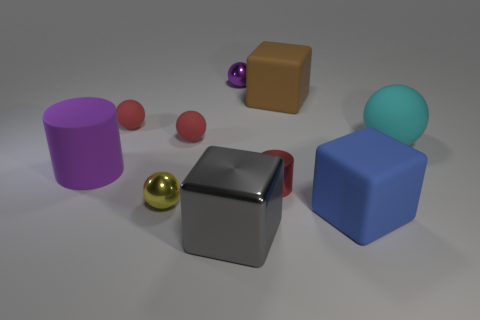Subtract all yellow shiny balls. How many balls are left? 4 Subtract all blue cubes. How many cubes are left? 2 Subtract all blocks. How many objects are left? 7 Subtract 0 blue cylinders. How many objects are left? 10 Subtract 1 cubes. How many cubes are left? 2 Subtract all purple cylinders. Subtract all red balls. How many cylinders are left? 1 Subtract all cyan spheres. How many blue cylinders are left? 0 Subtract all small yellow metal spheres. Subtract all purple metallic spheres. How many objects are left? 8 Add 6 small purple spheres. How many small purple spheres are left? 7 Add 7 tiny metal cylinders. How many tiny metal cylinders exist? 8 